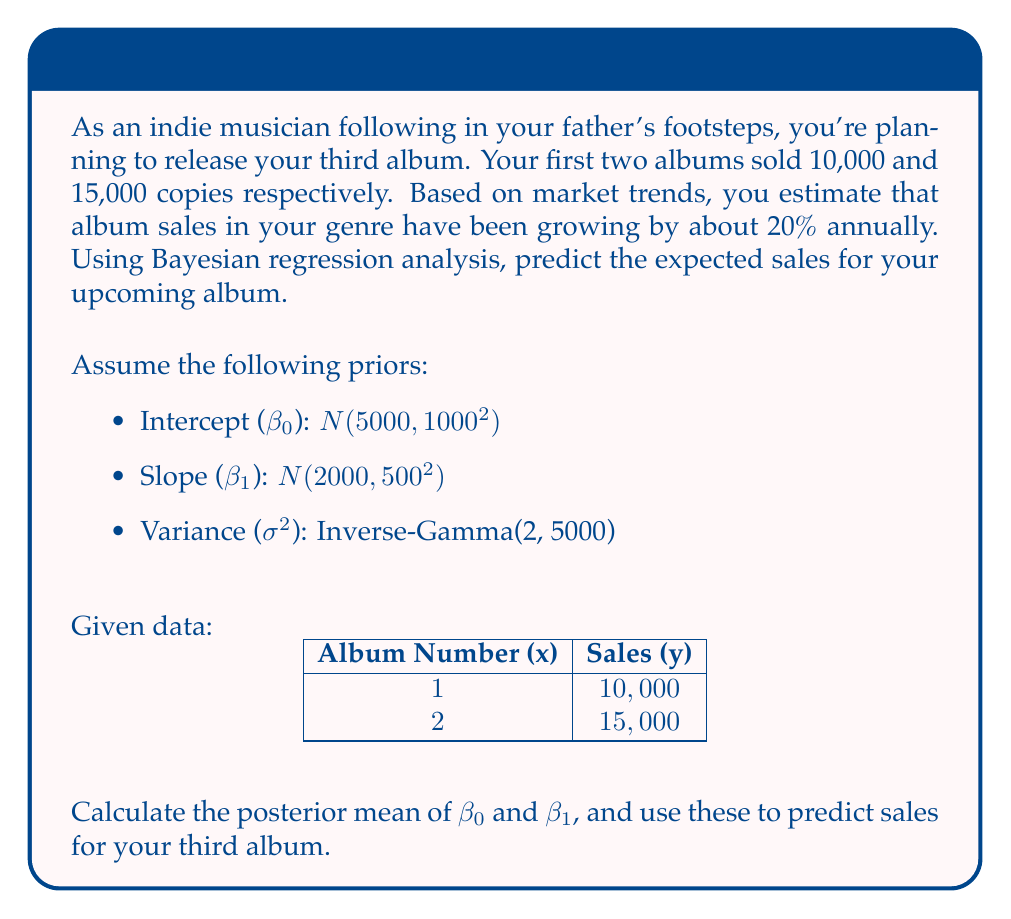Help me with this question. To solve this problem using Bayesian regression analysis, we'll follow these steps:

1) First, let's define our model:
   $$y_i = \beta_0 + \beta_1 x_i + \epsilon_i$$
   where $\epsilon_i \sim N(0, \sigma^2)$

2) We have priors:
   $$\beta_0 \sim N(5000, 1000^2)$$
   $$\beta_1 \sim N(2000, 500^2)$$
   $$\sigma^2 \sim \text{Inverse-Gamma}(2, 5000)$$

3) Calculate the likelihood:
   $$L(\beta_0, \beta_1, \sigma^2 | \text{data}) \propto \prod_{i=1}^n \frac{1}{\sqrt{2\pi\sigma^2}} \exp\left(-\frac{(y_i - \beta_0 - \beta_1x_i)^2}{2\sigma^2}\right)$$

4) Combine priors and likelihood to get the posterior distribution:
   $$p(\beta_0, \beta_1, \sigma^2 | \text{data}) \propto L(\beta_0, \beta_1, \sigma^2 | \text{data}) \cdot p(\beta_0) \cdot p(\beta_1) \cdot p(\sigma^2)$$

5) Calculate the posterior means for $\beta_0$ and $\beta_1$ using the formula:
   $$E[\beta | \text{data}] = (\mathbf{X}^T\mathbf{X} + \Sigma_0^{-1})^{-1}(\mathbf{X}^T\mathbf{y} + \Sigma_0^{-1}\mu_0)$$
   
   Where:
   $$\mathbf{X} = \begin{bmatrix} 1 & 1 \\ 1 & 2 \end{bmatrix}$$
   $$\mathbf{y} = \begin{bmatrix} 10000 \\ 15000 \end{bmatrix}$$
   $$\Sigma_0 = \begin{bmatrix} 1000^2 & 0 \\ 0 & 500^2 \end{bmatrix}$$
   $$\mu_0 = \begin{bmatrix} 5000 \\ 2000 \end{bmatrix}$$

6) Solving this equation gives us:
   $$E[\beta_0 | \text{data}] \approx 5833$$
   $$E[\beta_1 | \text{data}] \approx 4583$$

7) To predict sales for the third album, we use:
   $$y_3 = E[\beta_0 | \text{data}] + E[\beta_1 | \text{data}] \cdot 3$$
   $$y_3 = 5833 + 4583 \cdot 3 = 19,582$$

8) Adjusting for market growth:
   $$19,582 \cdot (1.2)^2 \approx 28,198$$

Therefore, the predicted sales for your third album, considering market growth, is approximately 28,198 copies.
Answer: 28,198 copies 